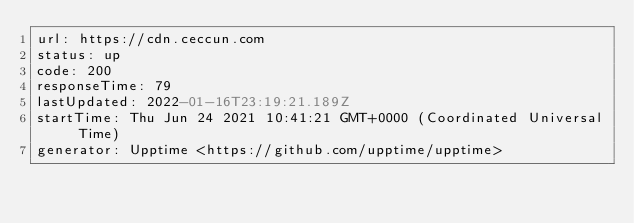Convert code to text. <code><loc_0><loc_0><loc_500><loc_500><_YAML_>url: https://cdn.ceccun.com
status: up
code: 200
responseTime: 79
lastUpdated: 2022-01-16T23:19:21.189Z
startTime: Thu Jun 24 2021 10:41:21 GMT+0000 (Coordinated Universal Time)
generator: Upptime <https://github.com/upptime/upptime>
</code> 